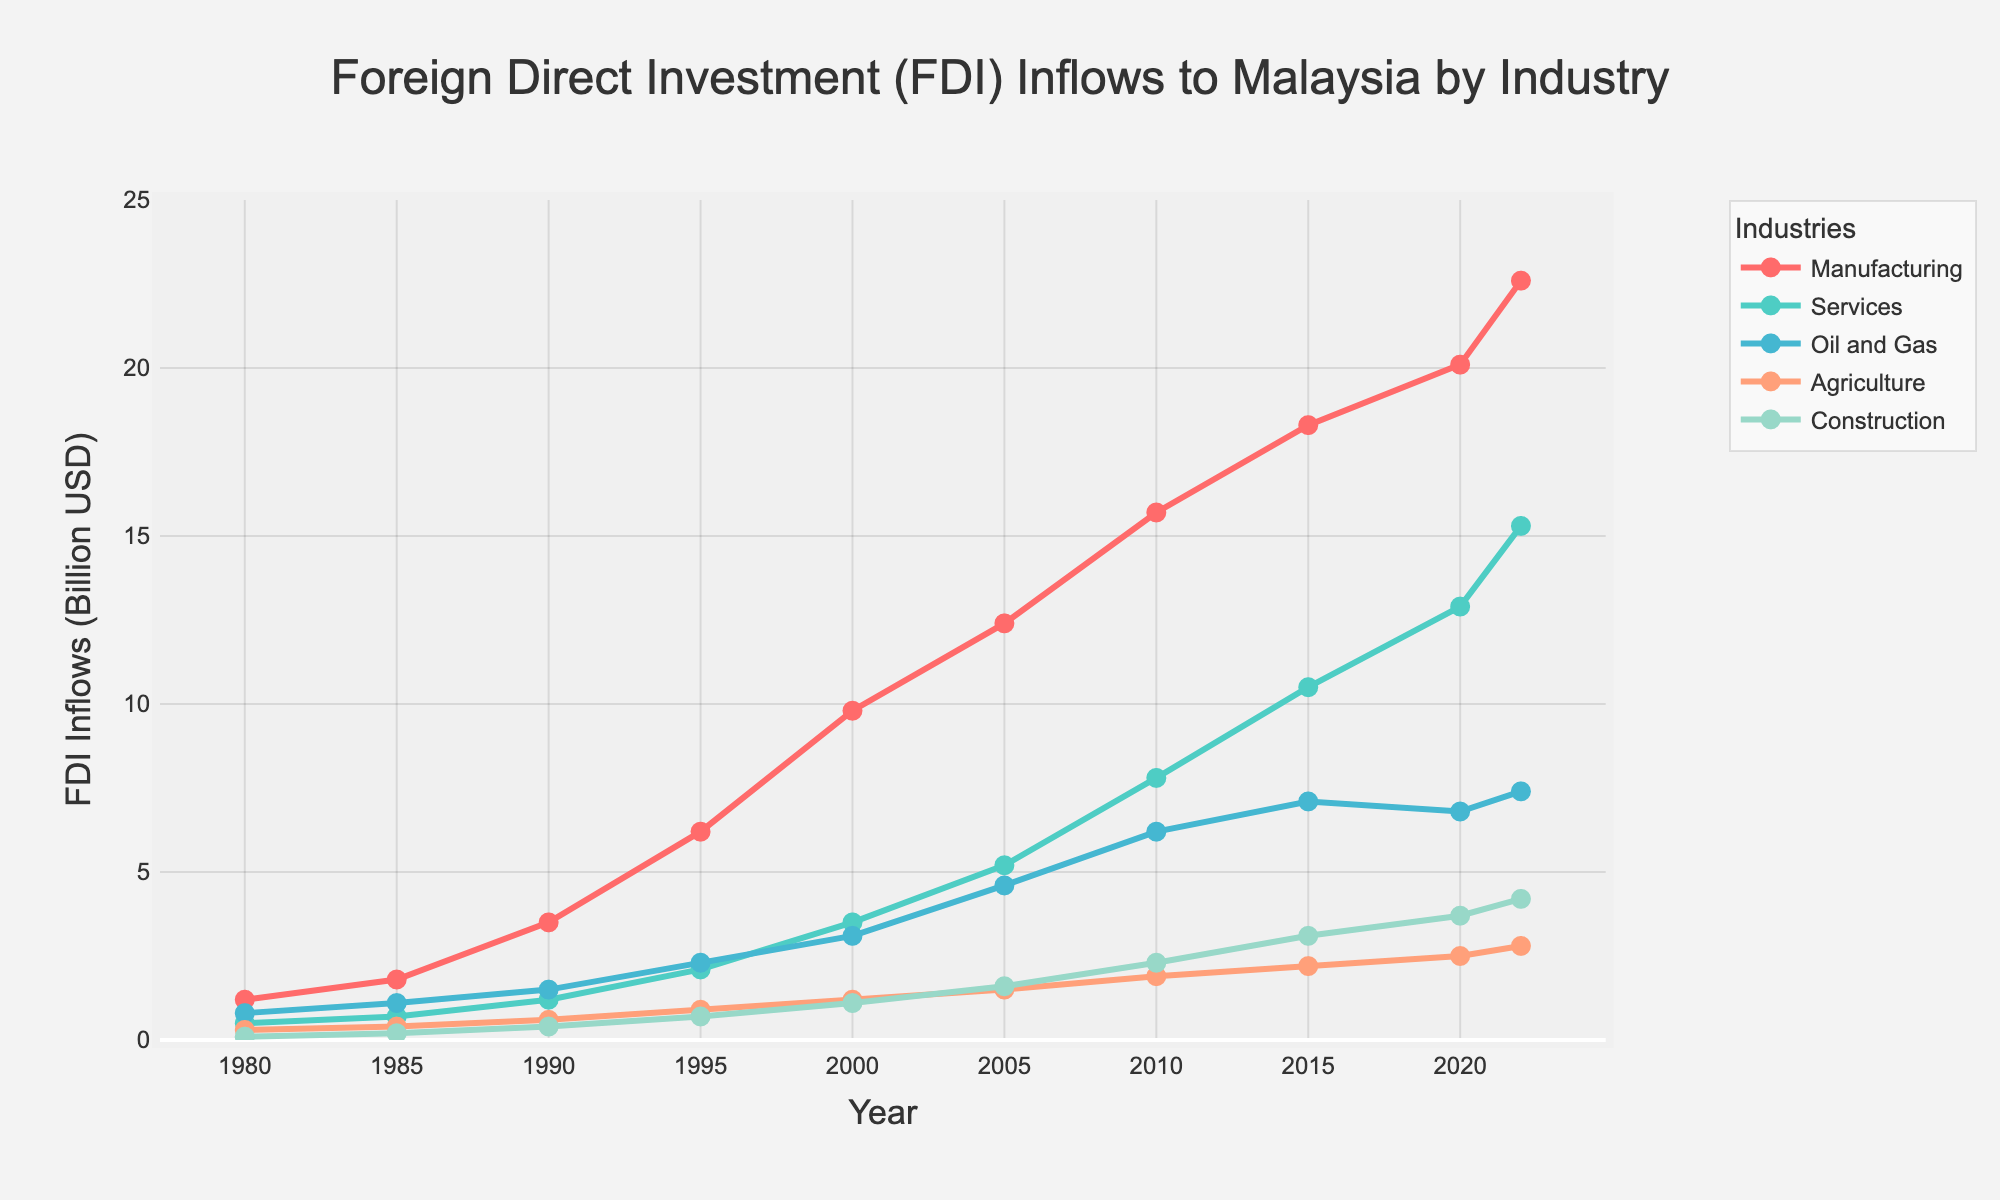What is the trend of FDI inflows in the manufacturing sector from 1980 to 2022? Observe the line corresponding to the manufacturing sector in the chart. From 1980 to 2022, the FDI inflows in manufacturing show a consistent upward trend, starting at 1.2 billion USD in 1980 and reaching 22.6 billion USD in 2022
Answer: An upward trend In which year did the services sector first surpass 10 billion USD in FDI inflows? Follow the line for the services sector and identify the point where it first crosses the 10 billion USD mark. The services sector surpassed 10 billion USD in FDI inflows in the year 2015
Answer: 2015 What is the difference in FDI inflows to the oil and gas sector between 2000 and 2020? Look at the FDI inflows to the oil and gas sector for the years 2000 and 2020. The FDI in 2000 was 3.1 billion USD and in 2020, it was 6.8 billion USD. The difference is 6.8 - 3.1 = 3.7 billion USD
Answer: 3.7 billion USD Which sector had the smallest FDI inflows in 2022 and what was the amount? Check each line at the year 2022 and identify the sector with the lowest value. Construction had the smallest FDI inflows in 2022, amounting to 4.2 billion USD
Answer: Construction, 4.2 billion USD Calculate the average FDI inflows across all sectors in the year 1995. Sum the FDI inflows for all sectors in 1995 and divide by the number of sectors. The values are 6.2 (Manufacturing), 2.1 (Services), 2.3 (Oil and Gas), 0.9 (Agriculture), and 0.7 (Construction). The sum is 6.2 + 2.1 + 2.3 + 0.9 + 0.7 = 12.2 billion USD. The average is 12.2 / 5 = 2.44 billion USD
Answer: 2.44 billion USD How did FDI inflows in the agriculture sector change from 1985 to 2010? Observe the line for the agriculture sector from 1985 to 2010. The FDI inflows increased from 0.4 billion USD in 1985 to 1.9 billion USD in 2010
Answer: Increased Which sector had the highest growth rate in FDI inflows between 1980 and 2022? Calculate the growth rate for each sector: [(FDI in 2022 - FDI in 1980)/FDI in 1980] * 100. Manufacturing had the growth from 1.2 to 22.6, Services from 0.5 to 15.3, Oil and Gas from 0.8 to 7.4, Agriculture from 0.3 to 2.8, and Construction from 0.1 to 4.2. Manufacturing's growth rate is (22.6 - 1.2) / 1.2 * 100 = 1783.33%, Services is (15.3 - 0.5) / 0.5 * 100 = 2960%, Oil and Gas is (7.4 - 0.8) / 0.8 * 100 = 825%, Agriculture is (2.8 - 0.3) / 0.3 * 100 = 833.33%, Construction is (4.2 - 0.1) / 0.1 * 100 = 4100%. Therefore, Construction had the highest growth rate
Answer: Construction Between which consecutive years did the manufacturing sector see the largest increase in FDI inflows? Examine the line for the manufacturing sector and find the largest vertical gap between consecutive years. The largest increase was between 1985 (1.8 billion USD) and 1990 (3.5 billion USD) giving an increase of 3.5 - 1.8 = 1.7 billion USD
Answer: 1985-1990 